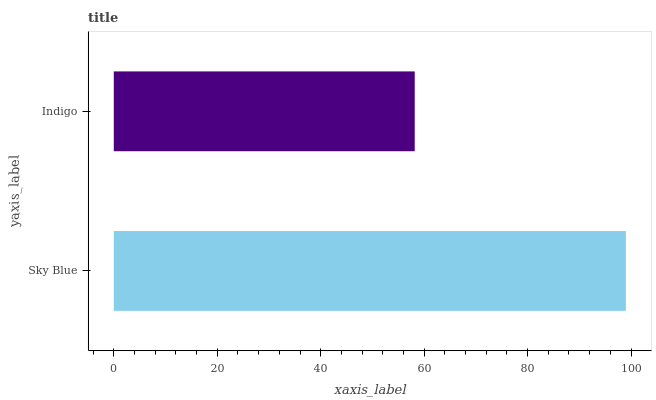Is Indigo the minimum?
Answer yes or no. Yes. Is Sky Blue the maximum?
Answer yes or no. Yes. Is Indigo the maximum?
Answer yes or no. No. Is Sky Blue greater than Indigo?
Answer yes or no. Yes. Is Indigo less than Sky Blue?
Answer yes or no. Yes. Is Indigo greater than Sky Blue?
Answer yes or no. No. Is Sky Blue less than Indigo?
Answer yes or no. No. Is Sky Blue the high median?
Answer yes or no. Yes. Is Indigo the low median?
Answer yes or no. Yes. Is Indigo the high median?
Answer yes or no. No. Is Sky Blue the low median?
Answer yes or no. No. 